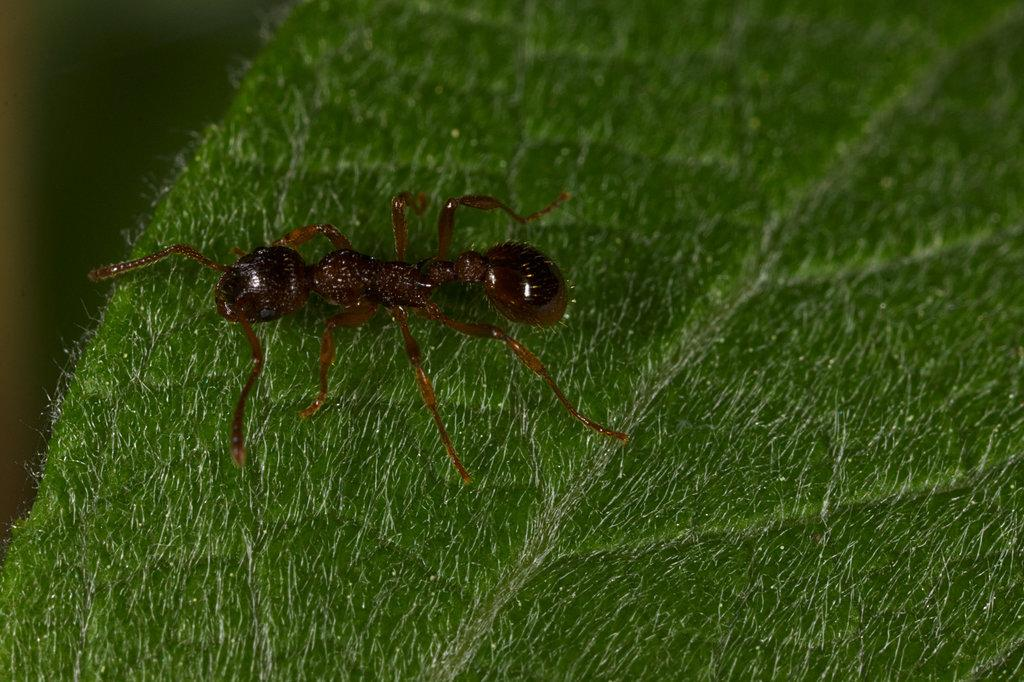What is present on the leaf in the image? There is a small insect on the leaf in the image. Can you describe the insect's location on the leaf? The insect is on the leaf in the image. What type of advice can be seen written on the apples in the image? There are no apples present in the image, and therefore no advice can be seen written on them. 